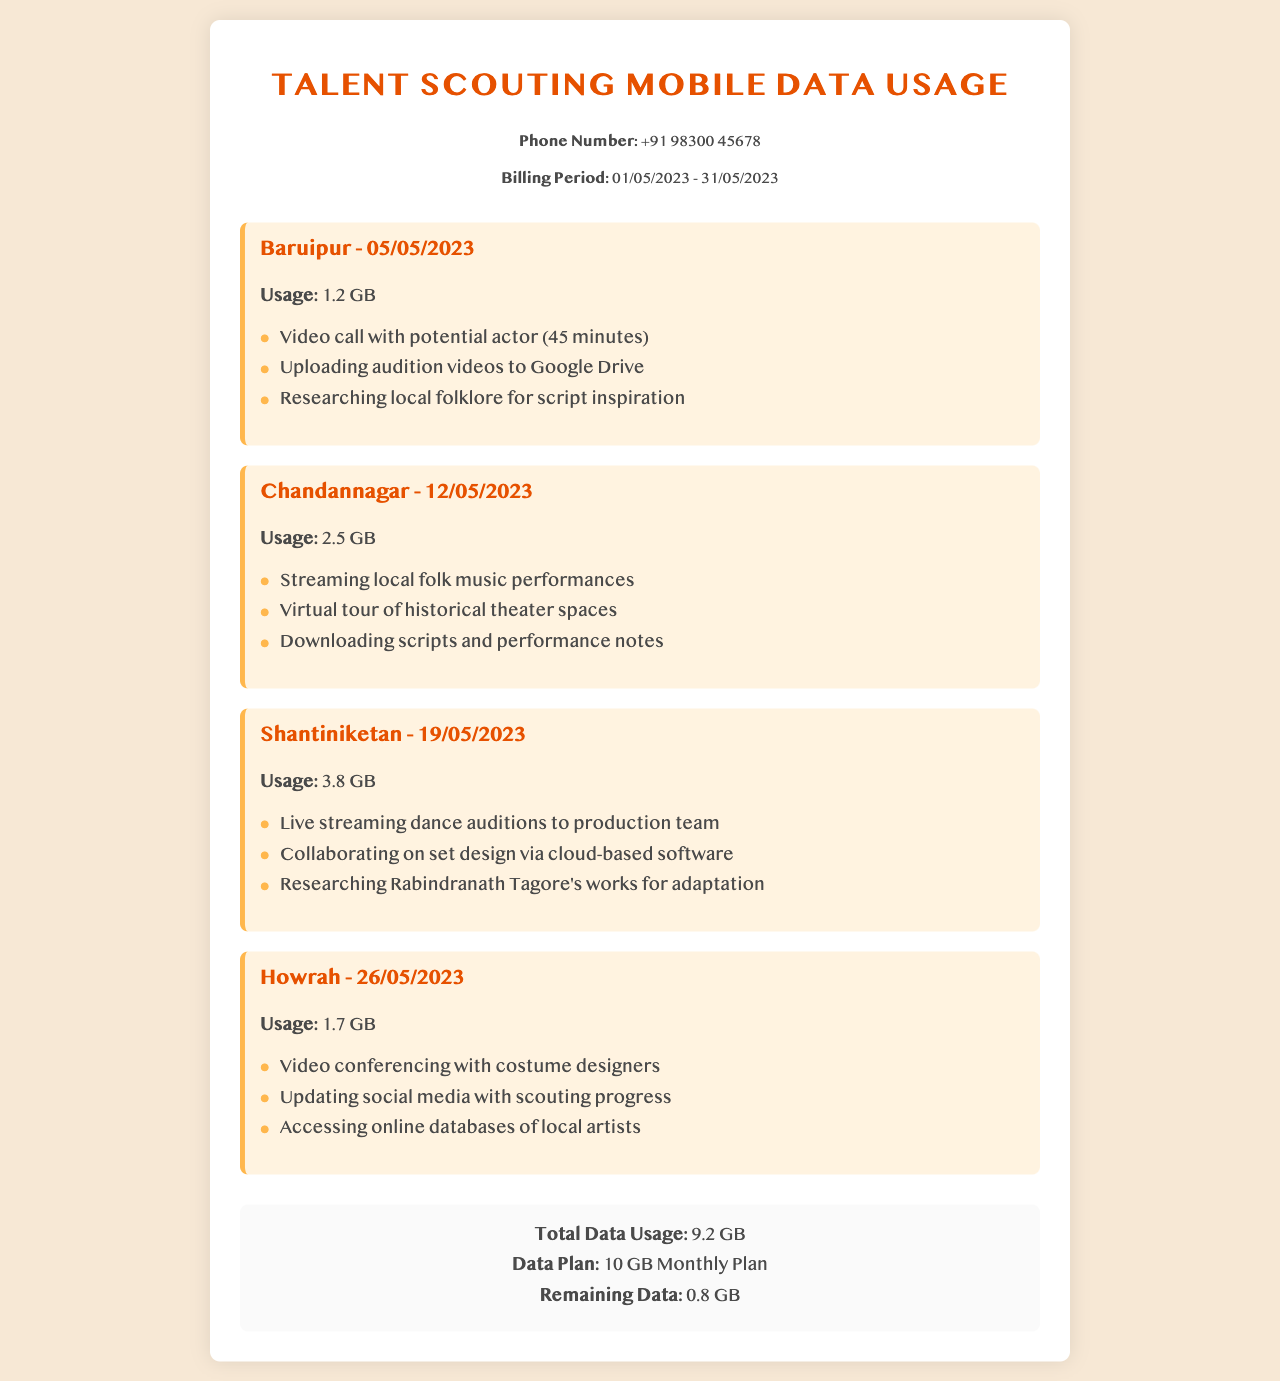what is the phone number listed? The document lists the phone number as +91 98300 45678.
Answer: +91 98300 45678 what is the billing period? The billing period is specified as from 01/05/2023 to 31/05/2023.
Answer: 01/05/2023 - 31/05/2023 how much data was used in Shantiniketan? The usage for Shantiniketan is recorded as 3.8 GB.
Answer: 3.8 GB what is the total data usage? Total data usage is summarized at the bottom and calculated as 1.2 GB + 2.5 GB + 3.8 GB + 1.7 GB = 9.2 GB.
Answer: 9.2 GB how much data remains from the monthly plan? The summary notes that there is 0.8 GB of remaining data from the 10 GB monthly plan.
Answer: 0.8 GB which town had the highest data usage? Shantiniketan has the highest data usage recorded among the listed towns at 3.8 GB.
Answer: Shantiniketan what was uploaded to Google Drive in Baruipur? The activities in Baruipur included uploading audition videos to Google Drive.
Answer: Audition videos what activity was done in Howrah related to social media? The usage in Howrah involved updating social media with scouting progress.
Answer: Updating social media what type of call was made in Baruipur? The call in Baruipur was a video call with a potential actor.
Answer: Video call 